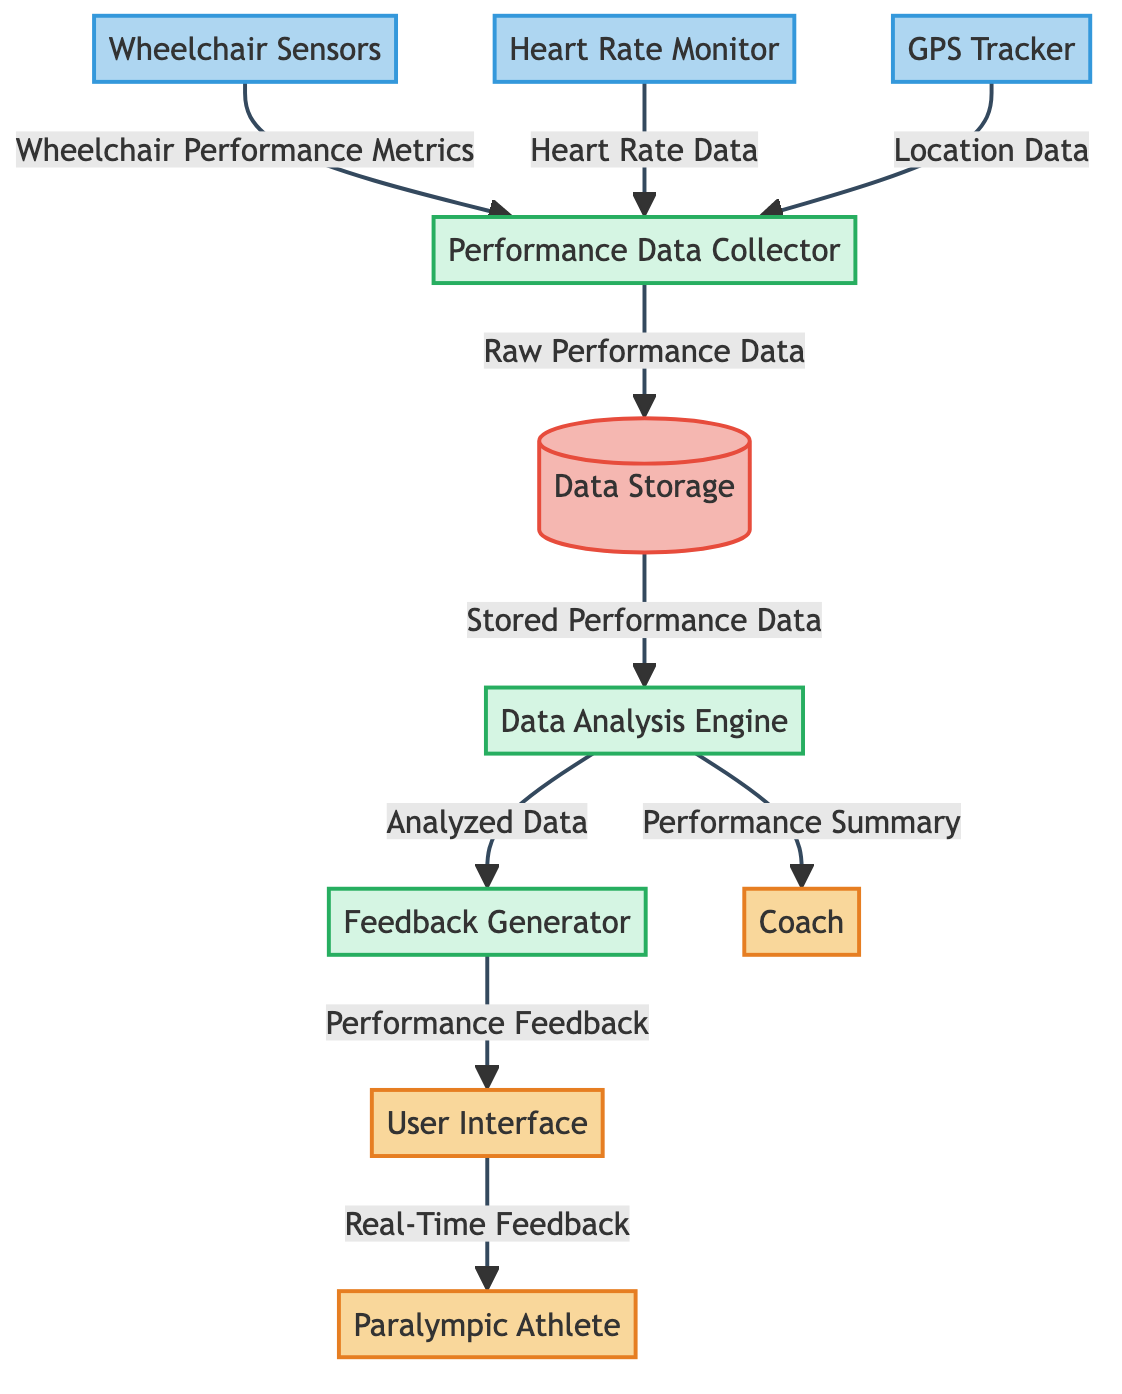What is the number of external entities in the diagram? There are three external entities depicted in the diagram: the Paralympic Athlete, User Interface, and Coach.
Answer: 3 What type of device captures heart rate data? The heart rate data is captured by the Heart Rate Monitor, which is categorized as a data source.
Answer: Heart Rate Monitor Which system analyzes the stored performance data? The system responsible for analyzing the stored performance data is the Data Analysis Engine, classified as a process.
Answer: Data Analysis Engine How many data flows are there in total? Upon reviewing the data flows provided, there are seven data flows illustrated in the diagram.
Answer: 7 What data does the GPS Tracker contribute to the Performance Data Collector? The GPS Tracker provides Location Data to the Performance Data Collector.
Answer: Location Data Which entity receives real-time feedback from the User Interface? The Paralympic Athlete is the entity that receives real-time feedback from the User Interface.
Answer: Paralympic Athlete What is produced by the Feedback Generator? The Feedback Generator produces Performance Feedback based on the analyzed data.
Answer: Performance Feedback Which system stores the raw performance data gathered from various sensors? The Data Storage is the system dedicated to storing the raw performance data collected from multiple sources.
Answer: Data Storage What type of system is the Performance Data Collector? The Performance Data Collector is classified as a process in the diagram.
Answer: Process 